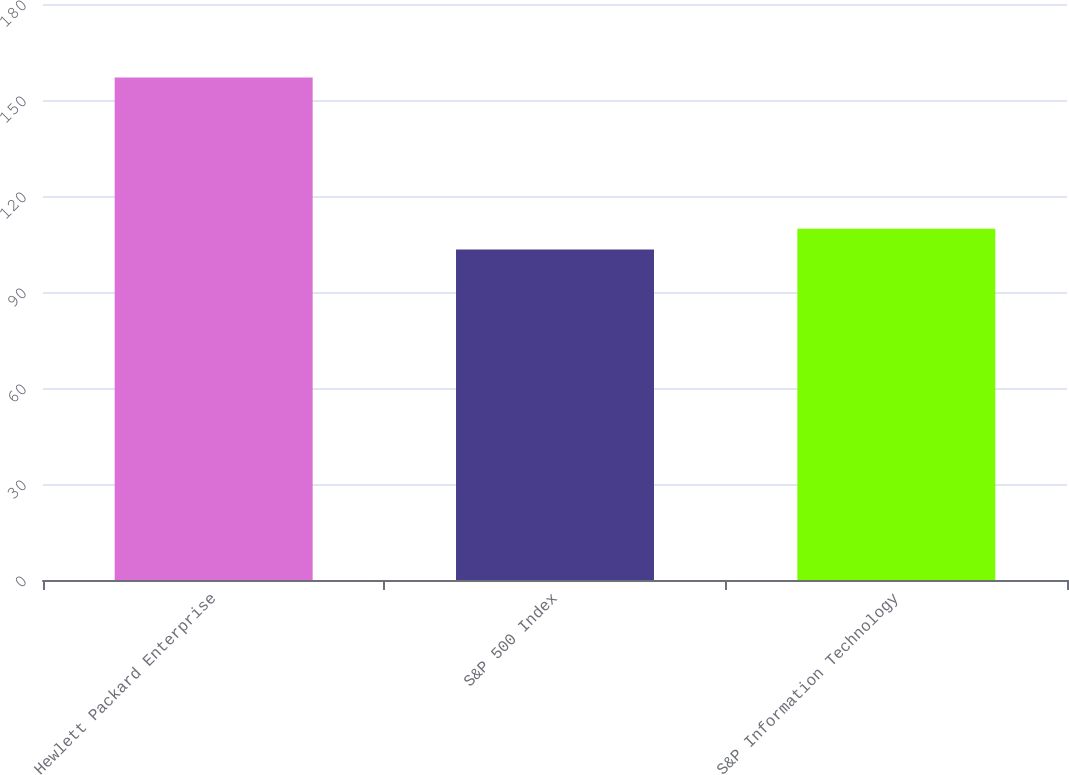Convert chart. <chart><loc_0><loc_0><loc_500><loc_500><bar_chart><fcel>Hewlett Packard Enterprise<fcel>S&P 500 Index<fcel>S&P Information Technology<nl><fcel>157<fcel>103.27<fcel>109.74<nl></chart> 